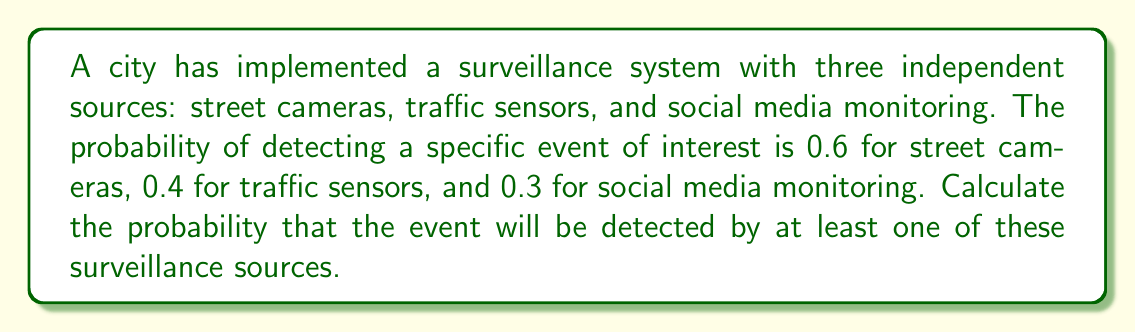Show me your answer to this math problem. To solve this problem, we'll use the concept of probability of the union of events and the principle of inclusion-exclusion.

Let's define the events:
A: Event detected by street cameras
B: Event detected by traffic sensors
C: Event detected by social media monitoring

We want to find P(A ∪ B ∪ C), which is the probability that the event is detected by at least one source.

Using the principle of inclusion-exclusion:

$$P(A \cup B \cup C) = P(A) + P(B) + P(C) - P(A \cap B) - P(A \cap C) - P(B \cap C) + P(A \cap B \cap C)$$

Given:
P(A) = 0.6
P(B) = 0.4
P(C) = 0.3

Since the sources are independent, we can calculate the intersections as follows:

$$P(A \cap B) = P(A) \cdot P(B) = 0.6 \cdot 0.4 = 0.24$$
$$P(A \cap C) = P(A) \cdot P(C) = 0.6 \cdot 0.3 = 0.18$$
$$P(B \cap C) = P(B) \cdot P(C) = 0.4 \cdot 0.3 = 0.12$$
$$P(A \cap B \cap C) = P(A) \cdot P(B) \cdot P(C) = 0.6 \cdot 0.4 \cdot 0.3 = 0.072$$

Now, let's substitute these values into the inclusion-exclusion formula:

$$\begin{align*}
P(A \cup B \cup C) &= 0.6 + 0.4 + 0.3 - 0.24 - 0.18 - 0.12 + 0.072 \\
&= 1.3 - 0.54 + 0.072 \\
&= 0.832
\end{align*}$$

Therefore, the probability that the event will be detected by at least one of the surveillance sources is 0.832 or 83.2%.
Answer: 0.832 or 83.2% 